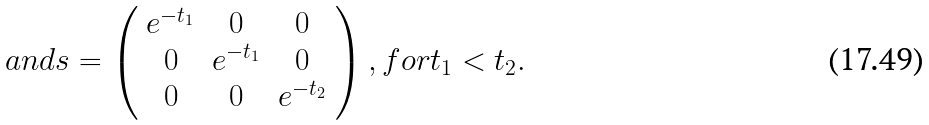Convert formula to latex. <formula><loc_0><loc_0><loc_500><loc_500>a n d s = \left ( \begin{array} { c c c } e ^ { - t _ { 1 } } & 0 & 0 \\ 0 & e ^ { - t _ { 1 } } & 0 \\ 0 & 0 & e ^ { - t _ { 2 } } \\ \end{array} \right ) , f o r t _ { 1 } < t _ { 2 } .</formula> 